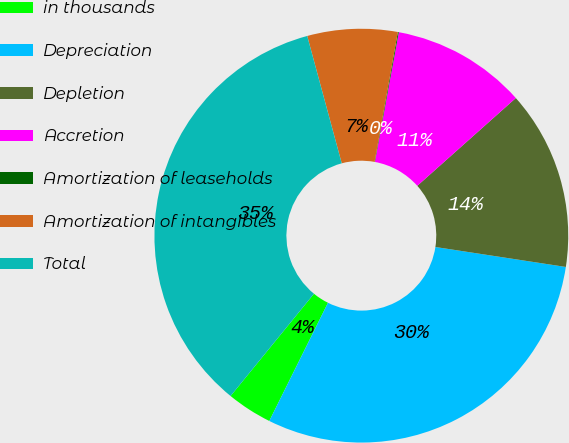Convert chart to OTSL. <chart><loc_0><loc_0><loc_500><loc_500><pie_chart><fcel>in thousands<fcel>Depreciation<fcel>Depletion<fcel>Accretion<fcel>Amortization of leaseholds<fcel>Amortization of intangibles<fcel>Total<nl><fcel>3.55%<fcel>29.92%<fcel>14.0%<fcel>10.52%<fcel>0.07%<fcel>7.04%<fcel>34.9%<nl></chart> 